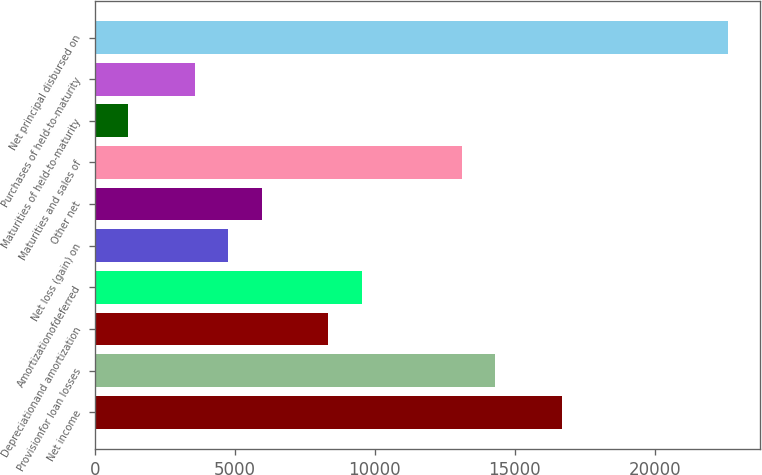<chart> <loc_0><loc_0><loc_500><loc_500><bar_chart><fcel>Net income<fcel>Provisionfor loan losses<fcel>Depreciationand amortization<fcel>Amortizationofdeferred<fcel>Net loss (gain) on<fcel>Other net<fcel>Maturities and sales of<fcel>Maturities of held-to-maturity<fcel>Purchases of held-to-maturity<fcel>Net principal disbursed on<nl><fcel>16678<fcel>14296<fcel>8341<fcel>9532<fcel>4768<fcel>5959<fcel>13105<fcel>1195<fcel>3577<fcel>22633<nl></chart> 